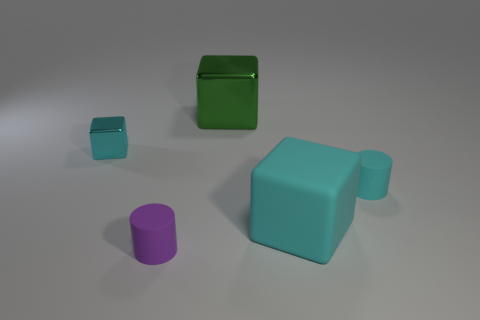The object that is behind the purple cylinder and in front of the small cyan matte thing is made of what material?
Your answer should be very brief. Rubber. Are there fewer things on the right side of the large metal cube than large cyan blocks that are to the left of the tiny cyan cylinder?
Offer a very short reply. No. What number of other things are the same size as the cyan cylinder?
Offer a very short reply. 2. What is the shape of the cyan object behind the matte object that is behind the block that is in front of the small shiny thing?
Ensure brevity in your answer.  Cube. What number of cyan things are tiny rubber cylinders or tiny objects?
Give a very brief answer. 2. What number of cyan shiny objects are to the right of the tiny object that is left of the tiny purple object?
Keep it short and to the point. 0. Is there anything else that is the same color as the small shiny block?
Offer a terse response. Yes. What shape is the big cyan object that is made of the same material as the small purple cylinder?
Provide a short and direct response. Cube. Is the color of the small shiny object the same as the big metal cube?
Provide a short and direct response. No. Is the material of the block left of the green metal block the same as the small cylinder that is behind the tiny purple cylinder?
Your answer should be compact. No. 